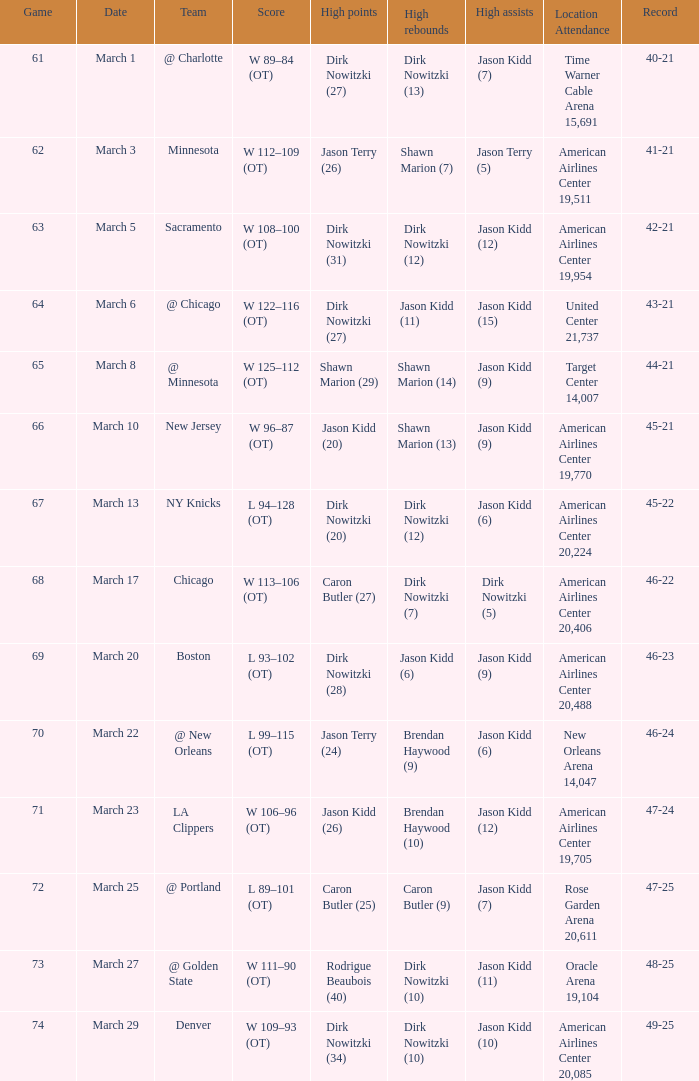How many games were played when the mavericks had a 46-22 record? 68.0. Could you parse the entire table as a dict? {'header': ['Game', 'Date', 'Team', 'Score', 'High points', 'High rebounds', 'High assists', 'Location Attendance', 'Record'], 'rows': [['61', 'March 1', '@ Charlotte', 'W 89–84 (OT)', 'Dirk Nowitzki (27)', 'Dirk Nowitzki (13)', 'Jason Kidd (7)', 'Time Warner Cable Arena 15,691', '40-21'], ['62', 'March 3', 'Minnesota', 'W 112–109 (OT)', 'Jason Terry (26)', 'Shawn Marion (7)', 'Jason Terry (5)', 'American Airlines Center 19,511', '41-21'], ['63', 'March 5', 'Sacramento', 'W 108–100 (OT)', 'Dirk Nowitzki (31)', 'Dirk Nowitzki (12)', 'Jason Kidd (12)', 'American Airlines Center 19,954', '42-21'], ['64', 'March 6', '@ Chicago', 'W 122–116 (OT)', 'Dirk Nowitzki (27)', 'Jason Kidd (11)', 'Jason Kidd (15)', 'United Center 21,737', '43-21'], ['65', 'March 8', '@ Minnesota', 'W 125–112 (OT)', 'Shawn Marion (29)', 'Shawn Marion (14)', 'Jason Kidd (9)', 'Target Center 14,007', '44-21'], ['66', 'March 10', 'New Jersey', 'W 96–87 (OT)', 'Jason Kidd (20)', 'Shawn Marion (13)', 'Jason Kidd (9)', 'American Airlines Center 19,770', '45-21'], ['67', 'March 13', 'NY Knicks', 'L 94–128 (OT)', 'Dirk Nowitzki (20)', 'Dirk Nowitzki (12)', 'Jason Kidd (6)', 'American Airlines Center 20,224', '45-22'], ['68', 'March 17', 'Chicago', 'W 113–106 (OT)', 'Caron Butler (27)', 'Dirk Nowitzki (7)', 'Dirk Nowitzki (5)', 'American Airlines Center 20,406', '46-22'], ['69', 'March 20', 'Boston', 'L 93–102 (OT)', 'Dirk Nowitzki (28)', 'Jason Kidd (6)', 'Jason Kidd (9)', 'American Airlines Center 20,488', '46-23'], ['70', 'March 22', '@ New Orleans', 'L 99–115 (OT)', 'Jason Terry (24)', 'Brendan Haywood (9)', 'Jason Kidd (6)', 'New Orleans Arena 14,047', '46-24'], ['71', 'March 23', 'LA Clippers', 'W 106–96 (OT)', 'Jason Kidd (26)', 'Brendan Haywood (10)', 'Jason Kidd (12)', 'American Airlines Center 19,705', '47-24'], ['72', 'March 25', '@ Portland', 'L 89–101 (OT)', 'Caron Butler (25)', 'Caron Butler (9)', 'Jason Kidd (7)', 'Rose Garden Arena 20,611', '47-25'], ['73', 'March 27', '@ Golden State', 'W 111–90 (OT)', 'Rodrigue Beaubois (40)', 'Dirk Nowitzki (10)', 'Jason Kidd (11)', 'Oracle Arena 19,104', '48-25'], ['74', 'March 29', 'Denver', 'W 109–93 (OT)', 'Dirk Nowitzki (34)', 'Dirk Nowitzki (10)', 'Jason Kidd (10)', 'American Airlines Center 20,085', '49-25']]} 